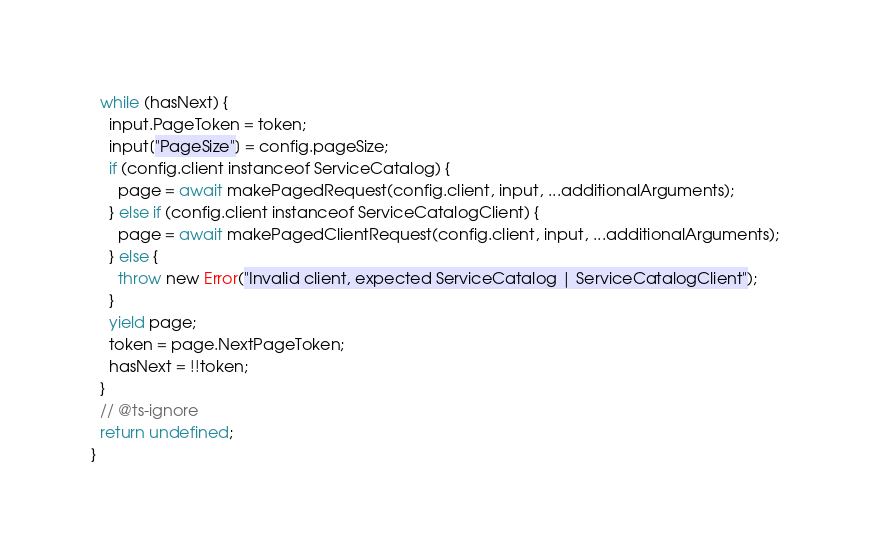<code> <loc_0><loc_0><loc_500><loc_500><_TypeScript_>  while (hasNext) {
    input.PageToken = token;
    input["PageSize"] = config.pageSize;
    if (config.client instanceof ServiceCatalog) {
      page = await makePagedRequest(config.client, input, ...additionalArguments);
    } else if (config.client instanceof ServiceCatalogClient) {
      page = await makePagedClientRequest(config.client, input, ...additionalArguments);
    } else {
      throw new Error("Invalid client, expected ServiceCatalog | ServiceCatalogClient");
    }
    yield page;
    token = page.NextPageToken;
    hasNext = !!token;
  }
  // @ts-ignore
  return undefined;
}
</code> 